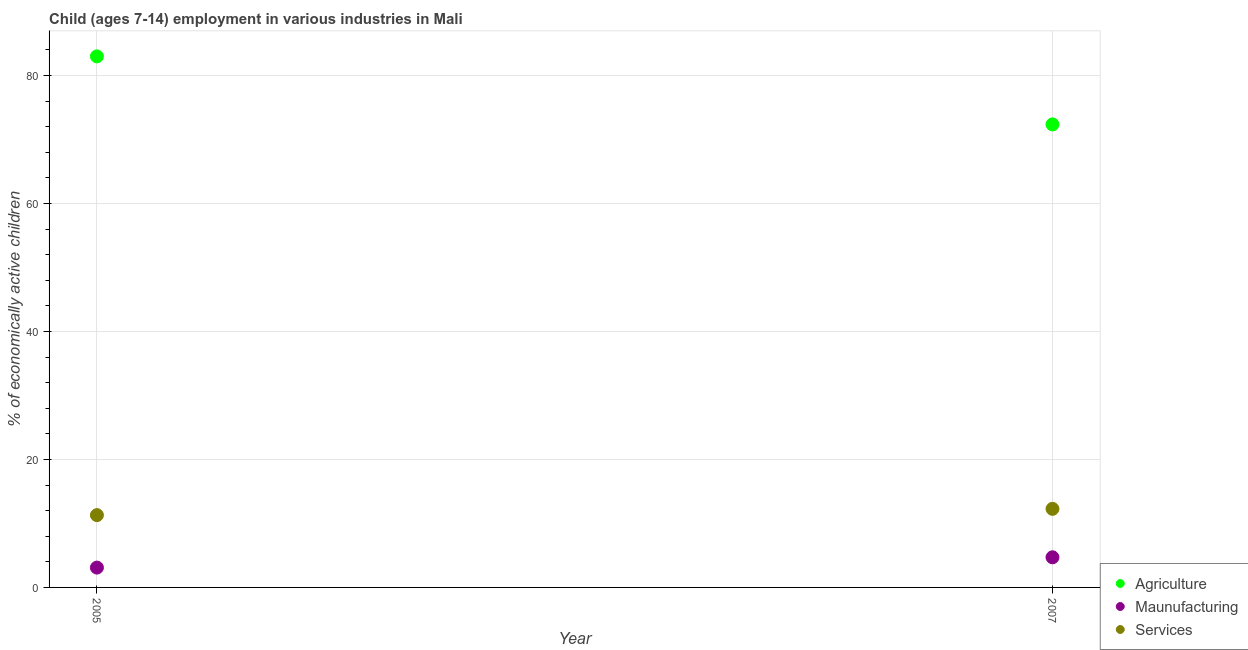Is the number of dotlines equal to the number of legend labels?
Provide a short and direct response. Yes. Across all years, what is the maximum percentage of economically active children in manufacturing?
Offer a very short reply. 4.71. In which year was the percentage of economically active children in manufacturing maximum?
Provide a short and direct response. 2007. What is the total percentage of economically active children in agriculture in the graph?
Your answer should be very brief. 155.37. What is the difference between the percentage of economically active children in manufacturing in 2005 and that in 2007?
Your response must be concise. -1.61. What is the difference between the percentage of economically active children in manufacturing in 2007 and the percentage of economically active children in agriculture in 2005?
Offer a very short reply. -78.29. What is the average percentage of economically active children in services per year?
Your answer should be very brief. 11.79. In the year 2007, what is the difference between the percentage of economically active children in manufacturing and percentage of economically active children in services?
Offer a very short reply. -7.57. In how many years, is the percentage of economically active children in agriculture greater than 8 %?
Ensure brevity in your answer.  2. What is the ratio of the percentage of economically active children in services in 2005 to that in 2007?
Your answer should be compact. 0.92. Is the percentage of economically active children in services in 2005 less than that in 2007?
Provide a short and direct response. Yes. Does the percentage of economically active children in manufacturing monotonically increase over the years?
Offer a terse response. Yes. Is the percentage of economically active children in agriculture strictly greater than the percentage of economically active children in manufacturing over the years?
Offer a very short reply. Yes. Is the percentage of economically active children in agriculture strictly less than the percentage of economically active children in services over the years?
Provide a short and direct response. No. What is the difference between two consecutive major ticks on the Y-axis?
Offer a very short reply. 20. Are the values on the major ticks of Y-axis written in scientific E-notation?
Offer a very short reply. No. Does the graph contain any zero values?
Ensure brevity in your answer.  No. Does the graph contain grids?
Keep it short and to the point. Yes. How many legend labels are there?
Your answer should be very brief. 3. What is the title of the graph?
Offer a terse response. Child (ages 7-14) employment in various industries in Mali. Does "Total employers" appear as one of the legend labels in the graph?
Offer a terse response. No. What is the label or title of the Y-axis?
Make the answer very short. % of economically active children. What is the % of economically active children in Agriculture in 2005?
Make the answer very short. 83. What is the % of economically active children in Maunufacturing in 2005?
Keep it short and to the point. 3.1. What is the % of economically active children of Agriculture in 2007?
Your answer should be very brief. 72.37. What is the % of economically active children in Maunufacturing in 2007?
Offer a very short reply. 4.71. What is the % of economically active children in Services in 2007?
Ensure brevity in your answer.  12.28. Across all years, what is the maximum % of economically active children in Maunufacturing?
Provide a succinct answer. 4.71. Across all years, what is the maximum % of economically active children in Services?
Your answer should be compact. 12.28. Across all years, what is the minimum % of economically active children of Agriculture?
Provide a succinct answer. 72.37. Across all years, what is the minimum % of economically active children of Maunufacturing?
Your response must be concise. 3.1. What is the total % of economically active children in Agriculture in the graph?
Provide a succinct answer. 155.37. What is the total % of economically active children in Maunufacturing in the graph?
Make the answer very short. 7.81. What is the total % of economically active children in Services in the graph?
Your answer should be compact. 23.58. What is the difference between the % of economically active children in Agriculture in 2005 and that in 2007?
Keep it short and to the point. 10.63. What is the difference between the % of economically active children of Maunufacturing in 2005 and that in 2007?
Ensure brevity in your answer.  -1.61. What is the difference between the % of economically active children in Services in 2005 and that in 2007?
Provide a succinct answer. -0.98. What is the difference between the % of economically active children of Agriculture in 2005 and the % of economically active children of Maunufacturing in 2007?
Keep it short and to the point. 78.29. What is the difference between the % of economically active children of Agriculture in 2005 and the % of economically active children of Services in 2007?
Keep it short and to the point. 70.72. What is the difference between the % of economically active children of Maunufacturing in 2005 and the % of economically active children of Services in 2007?
Your answer should be very brief. -9.18. What is the average % of economically active children in Agriculture per year?
Offer a terse response. 77.69. What is the average % of economically active children in Maunufacturing per year?
Provide a short and direct response. 3.9. What is the average % of economically active children of Services per year?
Provide a succinct answer. 11.79. In the year 2005, what is the difference between the % of economically active children of Agriculture and % of economically active children of Maunufacturing?
Your answer should be very brief. 79.9. In the year 2005, what is the difference between the % of economically active children in Agriculture and % of economically active children in Services?
Make the answer very short. 71.7. In the year 2007, what is the difference between the % of economically active children in Agriculture and % of economically active children in Maunufacturing?
Keep it short and to the point. 67.66. In the year 2007, what is the difference between the % of economically active children of Agriculture and % of economically active children of Services?
Offer a terse response. 60.09. In the year 2007, what is the difference between the % of economically active children in Maunufacturing and % of economically active children in Services?
Your response must be concise. -7.57. What is the ratio of the % of economically active children of Agriculture in 2005 to that in 2007?
Your answer should be very brief. 1.15. What is the ratio of the % of economically active children in Maunufacturing in 2005 to that in 2007?
Ensure brevity in your answer.  0.66. What is the ratio of the % of economically active children of Services in 2005 to that in 2007?
Provide a short and direct response. 0.92. What is the difference between the highest and the second highest % of economically active children of Agriculture?
Provide a short and direct response. 10.63. What is the difference between the highest and the second highest % of economically active children in Maunufacturing?
Offer a terse response. 1.61. What is the difference between the highest and the lowest % of economically active children of Agriculture?
Offer a very short reply. 10.63. What is the difference between the highest and the lowest % of economically active children of Maunufacturing?
Keep it short and to the point. 1.61. What is the difference between the highest and the lowest % of economically active children in Services?
Your answer should be very brief. 0.98. 